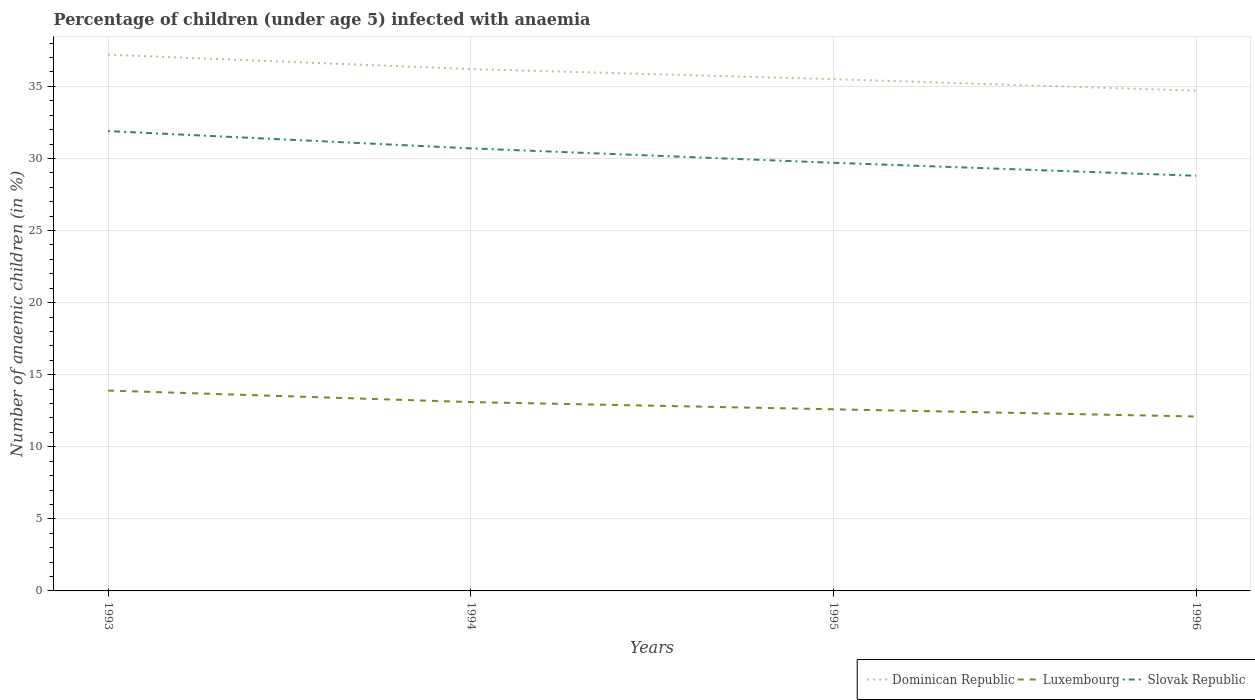Across all years, what is the maximum percentage of children infected with anaemia in in Luxembourg?
Offer a very short reply. 12.1. What is the total percentage of children infected with anaemia in in Dominican Republic in the graph?
Your answer should be very brief. 1.5. What is the difference between the highest and the second highest percentage of children infected with anaemia in in Slovak Republic?
Ensure brevity in your answer.  3.1. What is the difference between the highest and the lowest percentage of children infected with anaemia in in Dominican Republic?
Ensure brevity in your answer.  2. Is the percentage of children infected with anaemia in in Luxembourg strictly greater than the percentage of children infected with anaemia in in Slovak Republic over the years?
Give a very brief answer. Yes. How many years are there in the graph?
Make the answer very short. 4. Does the graph contain grids?
Provide a succinct answer. Yes. How are the legend labels stacked?
Your answer should be compact. Horizontal. What is the title of the graph?
Your answer should be compact. Percentage of children (under age 5) infected with anaemia. What is the label or title of the X-axis?
Ensure brevity in your answer.  Years. What is the label or title of the Y-axis?
Provide a short and direct response. Number of anaemic children (in %). What is the Number of anaemic children (in %) in Dominican Republic in 1993?
Offer a very short reply. 37.2. What is the Number of anaemic children (in %) in Luxembourg in 1993?
Your response must be concise. 13.9. What is the Number of anaemic children (in %) of Slovak Republic in 1993?
Ensure brevity in your answer.  31.9. What is the Number of anaemic children (in %) in Dominican Republic in 1994?
Offer a terse response. 36.2. What is the Number of anaemic children (in %) in Luxembourg in 1994?
Provide a short and direct response. 13.1. What is the Number of anaemic children (in %) in Slovak Republic in 1994?
Your response must be concise. 30.7. What is the Number of anaemic children (in %) in Dominican Republic in 1995?
Ensure brevity in your answer.  35.5. What is the Number of anaemic children (in %) of Slovak Republic in 1995?
Offer a terse response. 29.7. What is the Number of anaemic children (in %) in Dominican Republic in 1996?
Provide a succinct answer. 34.7. What is the Number of anaemic children (in %) of Luxembourg in 1996?
Your response must be concise. 12.1. What is the Number of anaemic children (in %) of Slovak Republic in 1996?
Give a very brief answer. 28.8. Across all years, what is the maximum Number of anaemic children (in %) of Dominican Republic?
Provide a short and direct response. 37.2. Across all years, what is the maximum Number of anaemic children (in %) in Luxembourg?
Keep it short and to the point. 13.9. Across all years, what is the maximum Number of anaemic children (in %) in Slovak Republic?
Offer a very short reply. 31.9. Across all years, what is the minimum Number of anaemic children (in %) of Dominican Republic?
Keep it short and to the point. 34.7. Across all years, what is the minimum Number of anaemic children (in %) of Slovak Republic?
Give a very brief answer. 28.8. What is the total Number of anaemic children (in %) of Dominican Republic in the graph?
Offer a terse response. 143.6. What is the total Number of anaemic children (in %) of Luxembourg in the graph?
Your answer should be very brief. 51.7. What is the total Number of anaemic children (in %) of Slovak Republic in the graph?
Offer a terse response. 121.1. What is the difference between the Number of anaemic children (in %) of Luxembourg in 1993 and that in 1994?
Ensure brevity in your answer.  0.8. What is the difference between the Number of anaemic children (in %) in Dominican Republic in 1993 and that in 1995?
Provide a short and direct response. 1.7. What is the difference between the Number of anaemic children (in %) of Luxembourg in 1993 and that in 1995?
Make the answer very short. 1.3. What is the difference between the Number of anaemic children (in %) in Dominican Republic in 1993 and that in 1996?
Your answer should be compact. 2.5. What is the difference between the Number of anaemic children (in %) of Luxembourg in 1993 and that in 1996?
Give a very brief answer. 1.8. What is the difference between the Number of anaemic children (in %) of Slovak Republic in 1993 and that in 1996?
Provide a short and direct response. 3.1. What is the difference between the Number of anaemic children (in %) in Dominican Republic in 1994 and that in 1995?
Keep it short and to the point. 0.7. What is the difference between the Number of anaemic children (in %) of Dominican Republic in 1994 and that in 1996?
Your response must be concise. 1.5. What is the difference between the Number of anaemic children (in %) in Luxembourg in 1994 and that in 1996?
Offer a terse response. 1. What is the difference between the Number of anaemic children (in %) of Slovak Republic in 1994 and that in 1996?
Offer a very short reply. 1.9. What is the difference between the Number of anaemic children (in %) in Luxembourg in 1995 and that in 1996?
Give a very brief answer. 0.5. What is the difference between the Number of anaemic children (in %) in Dominican Republic in 1993 and the Number of anaemic children (in %) in Luxembourg in 1994?
Provide a short and direct response. 24.1. What is the difference between the Number of anaemic children (in %) of Dominican Republic in 1993 and the Number of anaemic children (in %) of Slovak Republic in 1994?
Keep it short and to the point. 6.5. What is the difference between the Number of anaemic children (in %) in Luxembourg in 1993 and the Number of anaemic children (in %) in Slovak Republic in 1994?
Provide a succinct answer. -16.8. What is the difference between the Number of anaemic children (in %) of Dominican Republic in 1993 and the Number of anaemic children (in %) of Luxembourg in 1995?
Provide a short and direct response. 24.6. What is the difference between the Number of anaemic children (in %) in Dominican Republic in 1993 and the Number of anaemic children (in %) in Slovak Republic in 1995?
Your answer should be compact. 7.5. What is the difference between the Number of anaemic children (in %) of Luxembourg in 1993 and the Number of anaemic children (in %) of Slovak Republic in 1995?
Give a very brief answer. -15.8. What is the difference between the Number of anaemic children (in %) in Dominican Republic in 1993 and the Number of anaemic children (in %) in Luxembourg in 1996?
Make the answer very short. 25.1. What is the difference between the Number of anaemic children (in %) in Dominican Republic in 1993 and the Number of anaemic children (in %) in Slovak Republic in 1996?
Offer a terse response. 8.4. What is the difference between the Number of anaemic children (in %) in Luxembourg in 1993 and the Number of anaemic children (in %) in Slovak Republic in 1996?
Keep it short and to the point. -14.9. What is the difference between the Number of anaemic children (in %) of Dominican Republic in 1994 and the Number of anaemic children (in %) of Luxembourg in 1995?
Make the answer very short. 23.6. What is the difference between the Number of anaemic children (in %) in Dominican Republic in 1994 and the Number of anaemic children (in %) in Slovak Republic in 1995?
Provide a succinct answer. 6.5. What is the difference between the Number of anaemic children (in %) of Luxembourg in 1994 and the Number of anaemic children (in %) of Slovak Republic in 1995?
Provide a succinct answer. -16.6. What is the difference between the Number of anaemic children (in %) in Dominican Republic in 1994 and the Number of anaemic children (in %) in Luxembourg in 1996?
Provide a succinct answer. 24.1. What is the difference between the Number of anaemic children (in %) of Dominican Republic in 1994 and the Number of anaemic children (in %) of Slovak Republic in 1996?
Ensure brevity in your answer.  7.4. What is the difference between the Number of anaemic children (in %) in Luxembourg in 1994 and the Number of anaemic children (in %) in Slovak Republic in 1996?
Make the answer very short. -15.7. What is the difference between the Number of anaemic children (in %) in Dominican Republic in 1995 and the Number of anaemic children (in %) in Luxembourg in 1996?
Offer a terse response. 23.4. What is the difference between the Number of anaemic children (in %) in Luxembourg in 1995 and the Number of anaemic children (in %) in Slovak Republic in 1996?
Ensure brevity in your answer.  -16.2. What is the average Number of anaemic children (in %) of Dominican Republic per year?
Ensure brevity in your answer.  35.9. What is the average Number of anaemic children (in %) in Luxembourg per year?
Offer a terse response. 12.93. What is the average Number of anaemic children (in %) in Slovak Republic per year?
Offer a terse response. 30.27. In the year 1993, what is the difference between the Number of anaemic children (in %) in Dominican Republic and Number of anaemic children (in %) in Luxembourg?
Your answer should be compact. 23.3. In the year 1993, what is the difference between the Number of anaemic children (in %) in Dominican Republic and Number of anaemic children (in %) in Slovak Republic?
Provide a succinct answer. 5.3. In the year 1994, what is the difference between the Number of anaemic children (in %) of Dominican Republic and Number of anaemic children (in %) of Luxembourg?
Ensure brevity in your answer.  23.1. In the year 1994, what is the difference between the Number of anaemic children (in %) of Dominican Republic and Number of anaemic children (in %) of Slovak Republic?
Your answer should be very brief. 5.5. In the year 1994, what is the difference between the Number of anaemic children (in %) in Luxembourg and Number of anaemic children (in %) in Slovak Republic?
Keep it short and to the point. -17.6. In the year 1995, what is the difference between the Number of anaemic children (in %) of Dominican Republic and Number of anaemic children (in %) of Luxembourg?
Offer a terse response. 22.9. In the year 1995, what is the difference between the Number of anaemic children (in %) in Luxembourg and Number of anaemic children (in %) in Slovak Republic?
Offer a very short reply. -17.1. In the year 1996, what is the difference between the Number of anaemic children (in %) of Dominican Republic and Number of anaemic children (in %) of Luxembourg?
Keep it short and to the point. 22.6. In the year 1996, what is the difference between the Number of anaemic children (in %) in Dominican Republic and Number of anaemic children (in %) in Slovak Republic?
Make the answer very short. 5.9. In the year 1996, what is the difference between the Number of anaemic children (in %) in Luxembourg and Number of anaemic children (in %) in Slovak Republic?
Your answer should be very brief. -16.7. What is the ratio of the Number of anaemic children (in %) in Dominican Republic in 1993 to that in 1994?
Ensure brevity in your answer.  1.03. What is the ratio of the Number of anaemic children (in %) in Luxembourg in 1993 to that in 1994?
Your answer should be very brief. 1.06. What is the ratio of the Number of anaemic children (in %) in Slovak Republic in 1993 to that in 1994?
Your answer should be very brief. 1.04. What is the ratio of the Number of anaemic children (in %) in Dominican Republic in 1993 to that in 1995?
Your answer should be compact. 1.05. What is the ratio of the Number of anaemic children (in %) in Luxembourg in 1993 to that in 1995?
Give a very brief answer. 1.1. What is the ratio of the Number of anaemic children (in %) in Slovak Republic in 1993 to that in 1995?
Offer a very short reply. 1.07. What is the ratio of the Number of anaemic children (in %) of Dominican Republic in 1993 to that in 1996?
Your response must be concise. 1.07. What is the ratio of the Number of anaemic children (in %) in Luxembourg in 1993 to that in 1996?
Your response must be concise. 1.15. What is the ratio of the Number of anaemic children (in %) of Slovak Republic in 1993 to that in 1996?
Offer a very short reply. 1.11. What is the ratio of the Number of anaemic children (in %) in Dominican Republic in 1994 to that in 1995?
Your response must be concise. 1.02. What is the ratio of the Number of anaemic children (in %) in Luxembourg in 1994 to that in 1995?
Give a very brief answer. 1.04. What is the ratio of the Number of anaemic children (in %) in Slovak Republic in 1994 to that in 1995?
Offer a very short reply. 1.03. What is the ratio of the Number of anaemic children (in %) of Dominican Republic in 1994 to that in 1996?
Your answer should be very brief. 1.04. What is the ratio of the Number of anaemic children (in %) of Luxembourg in 1994 to that in 1996?
Make the answer very short. 1.08. What is the ratio of the Number of anaemic children (in %) in Slovak Republic in 1994 to that in 1996?
Provide a succinct answer. 1.07. What is the ratio of the Number of anaemic children (in %) in Dominican Republic in 1995 to that in 1996?
Your answer should be very brief. 1.02. What is the ratio of the Number of anaemic children (in %) in Luxembourg in 1995 to that in 1996?
Provide a succinct answer. 1.04. What is the ratio of the Number of anaemic children (in %) in Slovak Republic in 1995 to that in 1996?
Your answer should be compact. 1.03. What is the difference between the highest and the lowest Number of anaemic children (in %) of Luxembourg?
Your answer should be very brief. 1.8. 